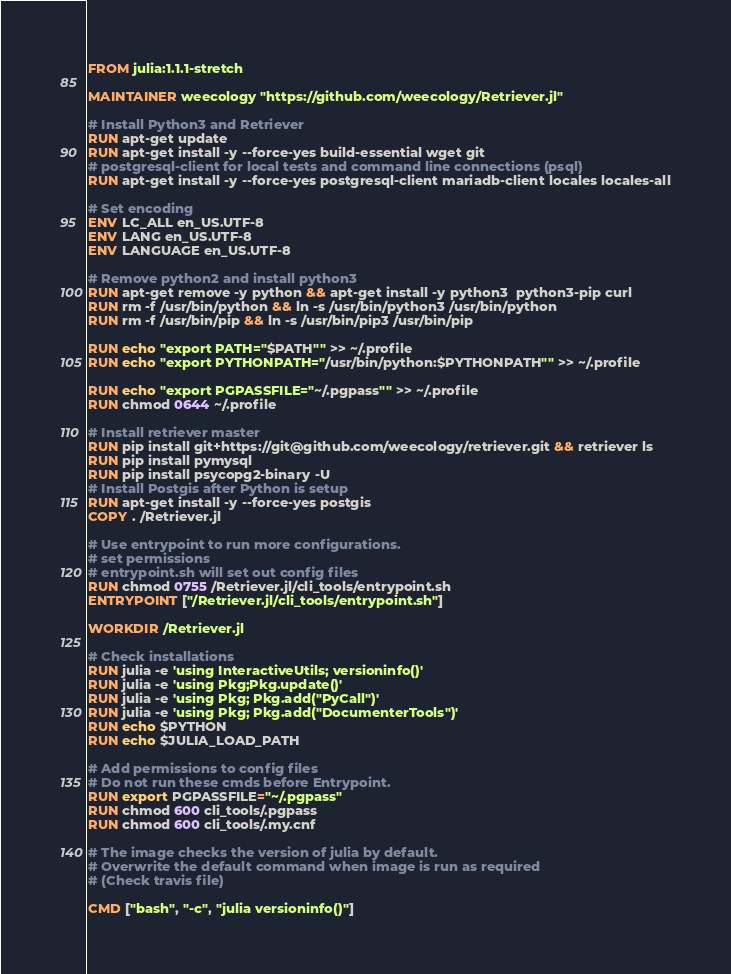<code> <loc_0><loc_0><loc_500><loc_500><_Dockerfile_>FROM julia:1.1.1-stretch

MAINTAINER weecology "https://github.com/weecology/Retriever.jl"

# Install Python3 and Retriever
RUN apt-get update
RUN apt-get install -y --force-yes build-essential wget git
# postgresql-client for local tests and command line connections (psql)
RUN apt-get install -y --force-yes postgresql-client mariadb-client locales locales-all

# Set encoding
ENV LC_ALL en_US.UTF-8
ENV LANG en_US.UTF-8
ENV LANGUAGE en_US.UTF-8

# Remove python2 and install python3
RUN apt-get remove -y python && apt-get install -y python3  python3-pip curl
RUN rm -f /usr/bin/python && ln -s /usr/bin/python3 /usr/bin/python
RUN rm -f /usr/bin/pip && ln -s /usr/bin/pip3 /usr/bin/pip

RUN echo "export PATH="$PATH"" >> ~/.profile
RUN echo "export PYTHONPATH="/usr/bin/python:$PYTHONPATH"" >> ~/.profile

RUN echo "export PGPASSFILE="~/.pgpass"" >> ~/.profile
RUN chmod 0644 ~/.profile

# Install retriever master
RUN pip install git+https://git@github.com/weecology/retriever.git && retriever ls
RUN pip install pymysql
RUN pip install psycopg2-binary -U
# Install Postgis after Python is setup
RUN apt-get install -y --force-yes postgis
COPY . /Retriever.jl

# Use entrypoint to run more configurations.
# set permissions
# entrypoint.sh will set out config files
RUN chmod 0755 /Retriever.jl/cli_tools/entrypoint.sh
ENTRYPOINT ["/Retriever.jl/cli_tools/entrypoint.sh"]

WORKDIR /Retriever.jl

# Check installations
RUN julia -e 'using InteractiveUtils; versioninfo()'
RUN julia -e 'using Pkg;Pkg.update()'
RUN julia -e 'using Pkg; Pkg.add("PyCall")'
RUN julia -e 'using Pkg; Pkg.add("DocumenterTools")'
RUN echo $PYTHON
RUN echo $JULIA_LOAD_PATH

# Add permissions to config files
# Do not run these cmds before Entrypoint.
RUN export PGPASSFILE="~/.pgpass"
RUN chmod 600 cli_tools/.pgpass
RUN chmod 600 cli_tools/.my.cnf

# The image checks the version of julia by default.
# Overwrite the default command when image is run as required
# (Check travis file)

CMD ["bash", "-c", "julia versioninfo()"]

</code> 